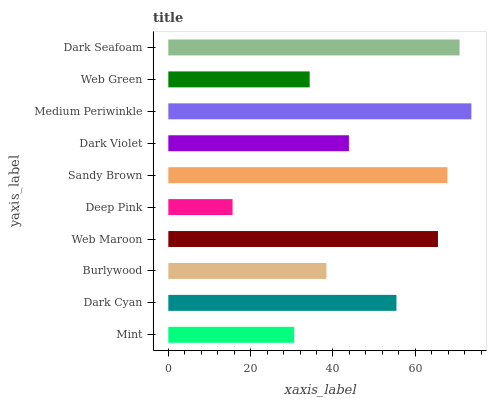Is Deep Pink the minimum?
Answer yes or no. Yes. Is Medium Periwinkle the maximum?
Answer yes or no. Yes. Is Dark Cyan the minimum?
Answer yes or no. No. Is Dark Cyan the maximum?
Answer yes or no. No. Is Dark Cyan greater than Mint?
Answer yes or no. Yes. Is Mint less than Dark Cyan?
Answer yes or no. Yes. Is Mint greater than Dark Cyan?
Answer yes or no. No. Is Dark Cyan less than Mint?
Answer yes or no. No. Is Dark Cyan the high median?
Answer yes or no. Yes. Is Dark Violet the low median?
Answer yes or no. Yes. Is Mint the high median?
Answer yes or no. No. Is Dark Seafoam the low median?
Answer yes or no. No. 